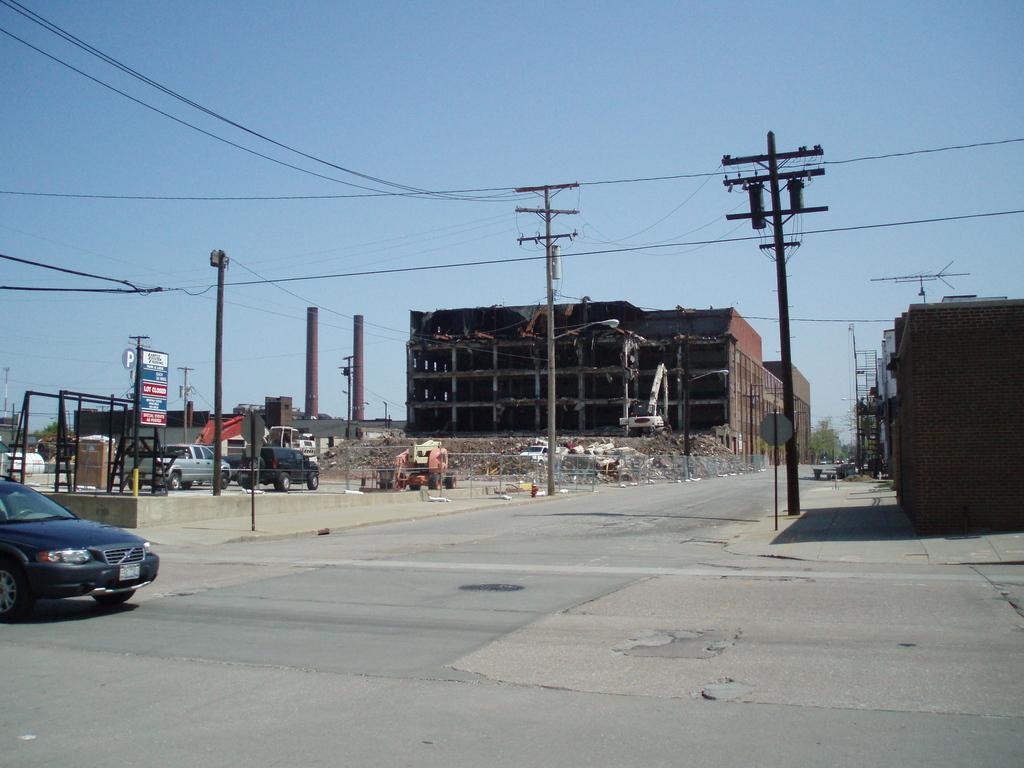What can be seen on the left side of the image? There are vehicles on the left side of the image. What else is present in the image besides vehicles? There are boards, current polls, wires, buildings, trees, and the sky is visible in the background of the image. Can you describe the condition of the sky in the image? The sky is blue and visible in the background of the image. What grade is the toothpaste mentioned in the image? There is no mention of toothpaste in the image. How does the head of the current polls look like in the image? The image does not show the heads of the current polls; it only shows the polls themselves. 